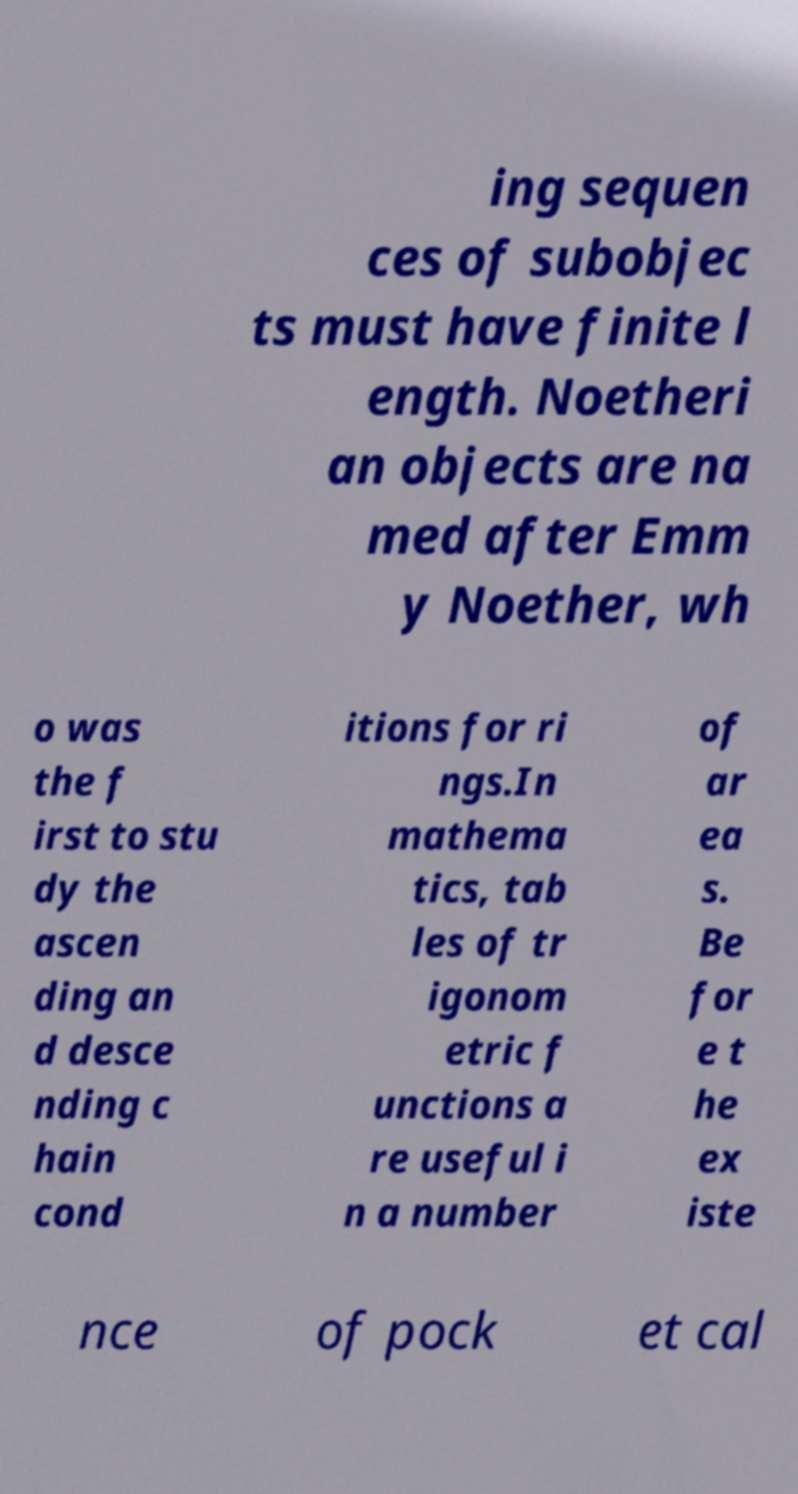Can you read and provide the text displayed in the image?This photo seems to have some interesting text. Can you extract and type it out for me? ing sequen ces of subobjec ts must have finite l ength. Noetheri an objects are na med after Emm y Noether, wh o was the f irst to stu dy the ascen ding an d desce nding c hain cond itions for ri ngs.In mathema tics, tab les of tr igonom etric f unctions a re useful i n a number of ar ea s. Be for e t he ex iste nce of pock et cal 